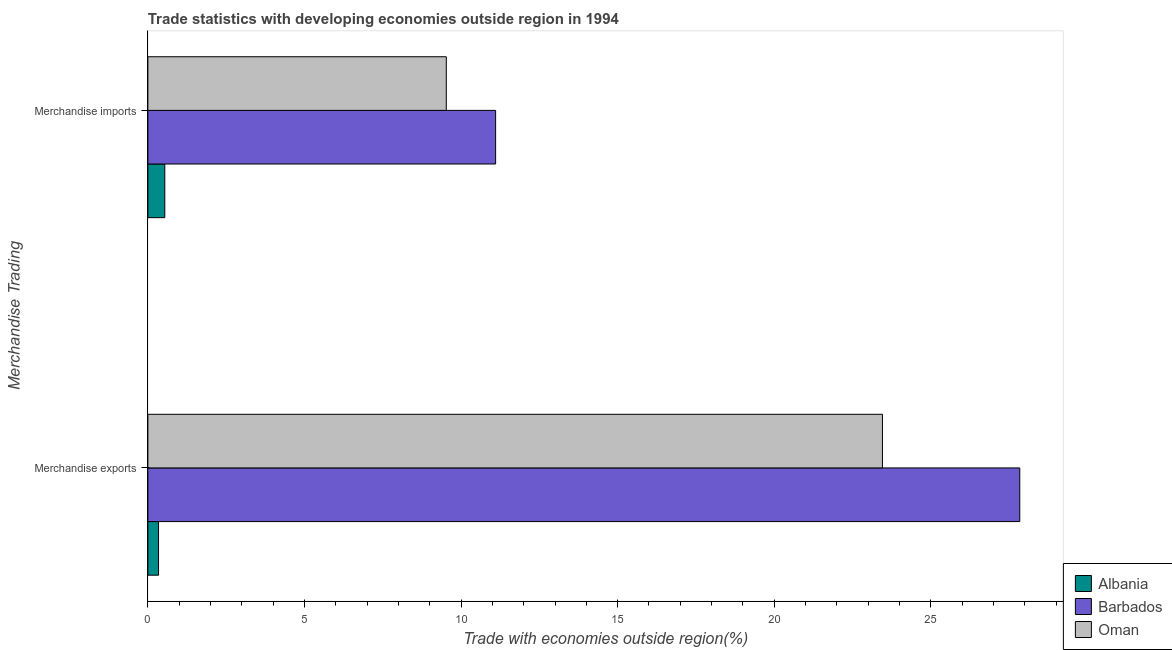How many different coloured bars are there?
Offer a terse response. 3. Are the number of bars per tick equal to the number of legend labels?
Your answer should be very brief. Yes. How many bars are there on the 2nd tick from the bottom?
Offer a very short reply. 3. What is the merchandise imports in Barbados?
Your response must be concise. 11.1. Across all countries, what is the maximum merchandise exports?
Give a very brief answer. 27.84. Across all countries, what is the minimum merchandise imports?
Your answer should be very brief. 0.54. In which country was the merchandise exports maximum?
Provide a succinct answer. Barbados. In which country was the merchandise exports minimum?
Your answer should be very brief. Albania. What is the total merchandise exports in the graph?
Provide a succinct answer. 51.64. What is the difference between the merchandise exports in Barbados and that in Oman?
Keep it short and to the point. 4.38. What is the difference between the merchandise imports in Oman and the merchandise exports in Barbados?
Give a very brief answer. -18.31. What is the average merchandise exports per country?
Your answer should be very brief. 17.21. What is the difference between the merchandise exports and merchandise imports in Albania?
Give a very brief answer. -0.2. What is the ratio of the merchandise exports in Barbados to that in Albania?
Provide a short and direct response. 81.73. Is the merchandise imports in Oman less than that in Albania?
Offer a very short reply. No. In how many countries, is the merchandise imports greater than the average merchandise imports taken over all countries?
Your answer should be very brief. 2. What does the 3rd bar from the top in Merchandise exports represents?
Your answer should be compact. Albania. What does the 3rd bar from the bottom in Merchandise exports represents?
Provide a succinct answer. Oman. How many bars are there?
Your answer should be very brief. 6. Are all the bars in the graph horizontal?
Provide a succinct answer. Yes. How many countries are there in the graph?
Offer a very short reply. 3. Are the values on the major ticks of X-axis written in scientific E-notation?
Your response must be concise. No. Does the graph contain grids?
Offer a very short reply. No. Where does the legend appear in the graph?
Your answer should be very brief. Bottom right. How many legend labels are there?
Keep it short and to the point. 3. What is the title of the graph?
Keep it short and to the point. Trade statistics with developing economies outside region in 1994. What is the label or title of the X-axis?
Provide a succinct answer. Trade with economies outside region(%). What is the label or title of the Y-axis?
Offer a very short reply. Merchandise Trading. What is the Trade with economies outside region(%) of Albania in Merchandise exports?
Ensure brevity in your answer.  0.34. What is the Trade with economies outside region(%) in Barbados in Merchandise exports?
Provide a succinct answer. 27.84. What is the Trade with economies outside region(%) of Oman in Merchandise exports?
Your response must be concise. 23.46. What is the Trade with economies outside region(%) in Albania in Merchandise imports?
Offer a very short reply. 0.54. What is the Trade with economies outside region(%) of Barbados in Merchandise imports?
Your answer should be very brief. 11.1. What is the Trade with economies outside region(%) in Oman in Merchandise imports?
Your response must be concise. 9.53. Across all Merchandise Trading, what is the maximum Trade with economies outside region(%) of Albania?
Your answer should be compact. 0.54. Across all Merchandise Trading, what is the maximum Trade with economies outside region(%) in Barbados?
Your answer should be very brief. 27.84. Across all Merchandise Trading, what is the maximum Trade with economies outside region(%) in Oman?
Give a very brief answer. 23.46. Across all Merchandise Trading, what is the minimum Trade with economies outside region(%) of Albania?
Provide a short and direct response. 0.34. Across all Merchandise Trading, what is the minimum Trade with economies outside region(%) in Barbados?
Your answer should be compact. 11.1. Across all Merchandise Trading, what is the minimum Trade with economies outside region(%) in Oman?
Your answer should be very brief. 9.53. What is the total Trade with economies outside region(%) in Albania in the graph?
Offer a very short reply. 0.88. What is the total Trade with economies outside region(%) of Barbados in the graph?
Make the answer very short. 38.94. What is the total Trade with economies outside region(%) of Oman in the graph?
Your answer should be compact. 32.98. What is the difference between the Trade with economies outside region(%) in Albania in Merchandise exports and that in Merchandise imports?
Your answer should be compact. -0.2. What is the difference between the Trade with economies outside region(%) in Barbados in Merchandise exports and that in Merchandise imports?
Ensure brevity in your answer.  16.74. What is the difference between the Trade with economies outside region(%) in Oman in Merchandise exports and that in Merchandise imports?
Offer a very short reply. 13.93. What is the difference between the Trade with economies outside region(%) in Albania in Merchandise exports and the Trade with economies outside region(%) in Barbados in Merchandise imports?
Make the answer very short. -10.76. What is the difference between the Trade with economies outside region(%) of Albania in Merchandise exports and the Trade with economies outside region(%) of Oman in Merchandise imports?
Ensure brevity in your answer.  -9.19. What is the difference between the Trade with economies outside region(%) in Barbados in Merchandise exports and the Trade with economies outside region(%) in Oman in Merchandise imports?
Ensure brevity in your answer.  18.31. What is the average Trade with economies outside region(%) in Albania per Merchandise Trading?
Provide a short and direct response. 0.44. What is the average Trade with economies outside region(%) in Barbados per Merchandise Trading?
Offer a very short reply. 19.47. What is the average Trade with economies outside region(%) of Oman per Merchandise Trading?
Provide a short and direct response. 16.49. What is the difference between the Trade with economies outside region(%) of Albania and Trade with economies outside region(%) of Barbados in Merchandise exports?
Your answer should be very brief. -27.5. What is the difference between the Trade with economies outside region(%) of Albania and Trade with economies outside region(%) of Oman in Merchandise exports?
Make the answer very short. -23.11. What is the difference between the Trade with economies outside region(%) in Barbados and Trade with economies outside region(%) in Oman in Merchandise exports?
Make the answer very short. 4.38. What is the difference between the Trade with economies outside region(%) in Albania and Trade with economies outside region(%) in Barbados in Merchandise imports?
Provide a short and direct response. -10.56. What is the difference between the Trade with economies outside region(%) in Albania and Trade with economies outside region(%) in Oman in Merchandise imports?
Your response must be concise. -8.99. What is the difference between the Trade with economies outside region(%) of Barbados and Trade with economies outside region(%) of Oman in Merchandise imports?
Provide a short and direct response. 1.58. What is the ratio of the Trade with economies outside region(%) of Albania in Merchandise exports to that in Merchandise imports?
Provide a short and direct response. 0.63. What is the ratio of the Trade with economies outside region(%) in Barbados in Merchandise exports to that in Merchandise imports?
Ensure brevity in your answer.  2.51. What is the ratio of the Trade with economies outside region(%) in Oman in Merchandise exports to that in Merchandise imports?
Offer a terse response. 2.46. What is the difference between the highest and the second highest Trade with economies outside region(%) of Albania?
Give a very brief answer. 0.2. What is the difference between the highest and the second highest Trade with economies outside region(%) in Barbados?
Provide a succinct answer. 16.74. What is the difference between the highest and the second highest Trade with economies outside region(%) of Oman?
Your response must be concise. 13.93. What is the difference between the highest and the lowest Trade with economies outside region(%) in Albania?
Offer a very short reply. 0.2. What is the difference between the highest and the lowest Trade with economies outside region(%) in Barbados?
Provide a succinct answer. 16.74. What is the difference between the highest and the lowest Trade with economies outside region(%) in Oman?
Offer a terse response. 13.93. 